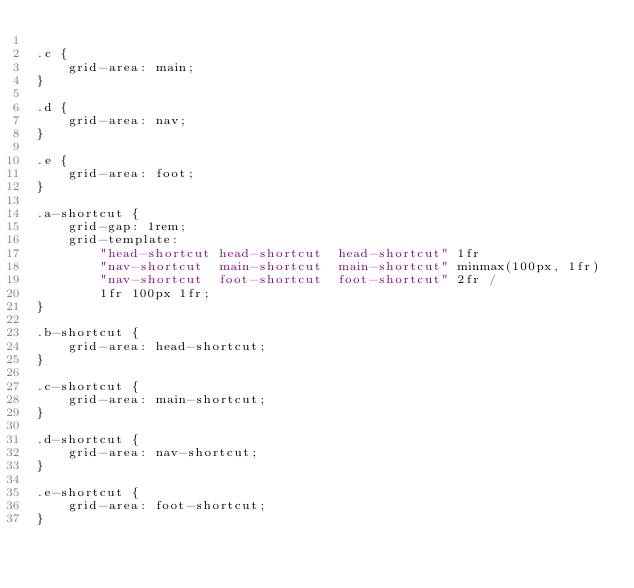<code> <loc_0><loc_0><loc_500><loc_500><_CSS_>
.c {
    grid-area: main;
}

.d {
    grid-area: nav;
}

.e {
    grid-area: foot;
}

.a-shortcut {
    grid-gap: 1rem;
    grid-template:
        "head-shortcut head-shortcut  head-shortcut" 1fr
        "nav-shortcut  main-shortcut  main-shortcut" minmax(100px, 1fr)
        "nav-shortcut  foot-shortcut  foot-shortcut" 2fr /
        1fr 100px 1fr;
}

.b-shortcut {
    grid-area: head-shortcut;
}

.c-shortcut {
    grid-area: main-shortcut;
}

.d-shortcut {
    grid-area: nav-shortcut;
}

.e-shortcut {
    grid-area: foot-shortcut;
}
</code> 